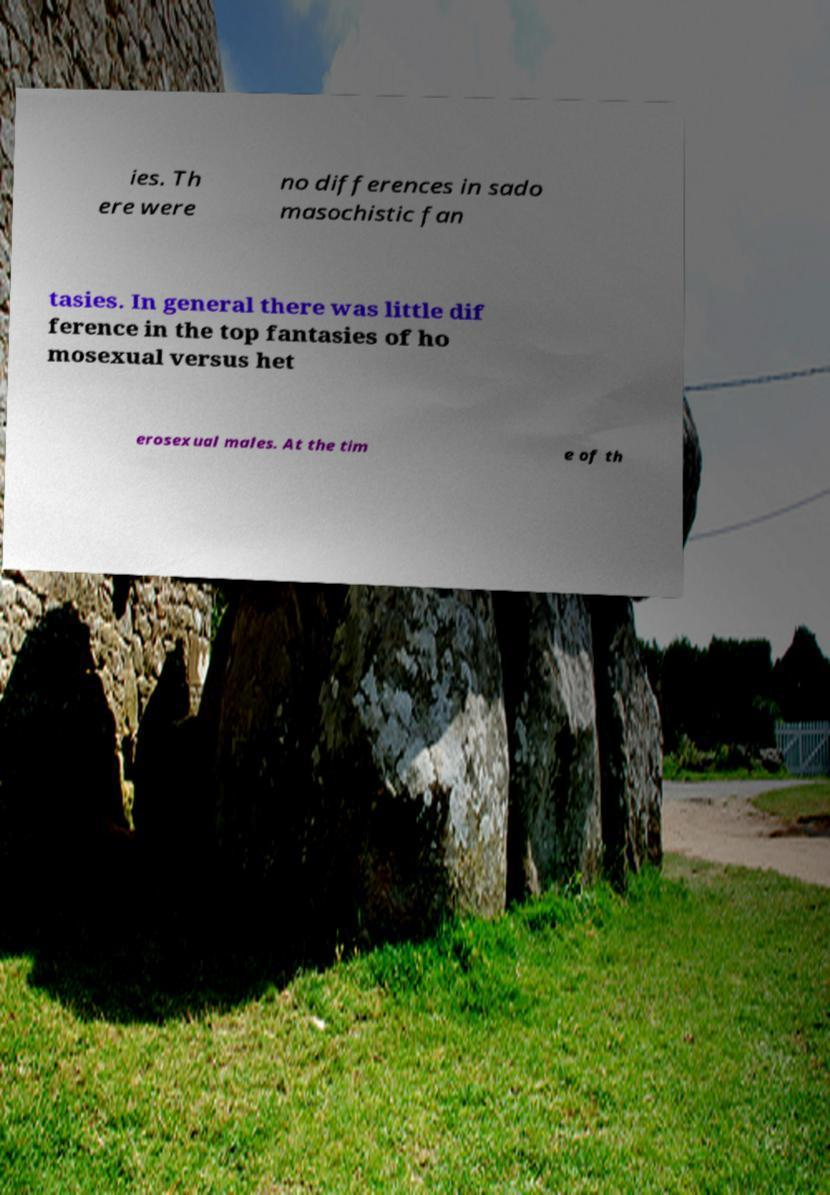I need the written content from this picture converted into text. Can you do that? ies. Th ere were no differences in sado masochistic fan tasies. In general there was little dif ference in the top fantasies of ho mosexual versus het erosexual males. At the tim e of th 